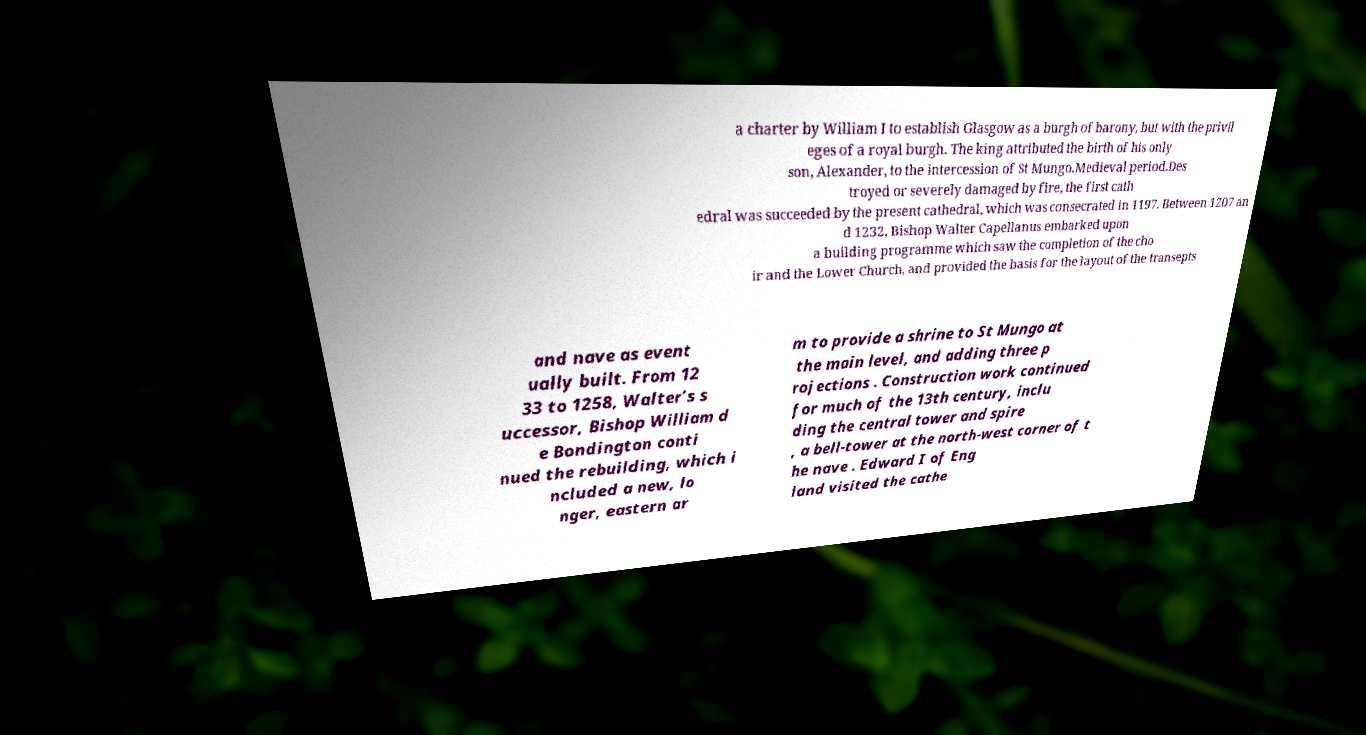Can you read and provide the text displayed in the image?This photo seems to have some interesting text. Can you extract and type it out for me? a charter by William I to establish Glasgow as a burgh of barony, but with the privil eges of a royal burgh. The king attributed the birth of his only son, Alexander, to the intercession of St Mungo.Medieval period.Des troyed or severely damaged by fire, the first cath edral was succeeded by the present cathedral, which was consecrated in 1197. Between 1207 an d 1232, Bishop Walter Capellanus embarked upon a building programme which saw the completion of the cho ir and the Lower Church, and provided the basis for the layout of the transepts and nave as event ually built. From 12 33 to 1258, Walter’s s uccessor, Bishop William d e Bondington conti nued the rebuilding, which i ncluded a new, lo nger, eastern ar m to provide a shrine to St Mungo at the main level, and adding three p rojections . Construction work continued for much of the 13th century, inclu ding the central tower and spire , a bell-tower at the north-west corner of t he nave . Edward I of Eng land visited the cathe 